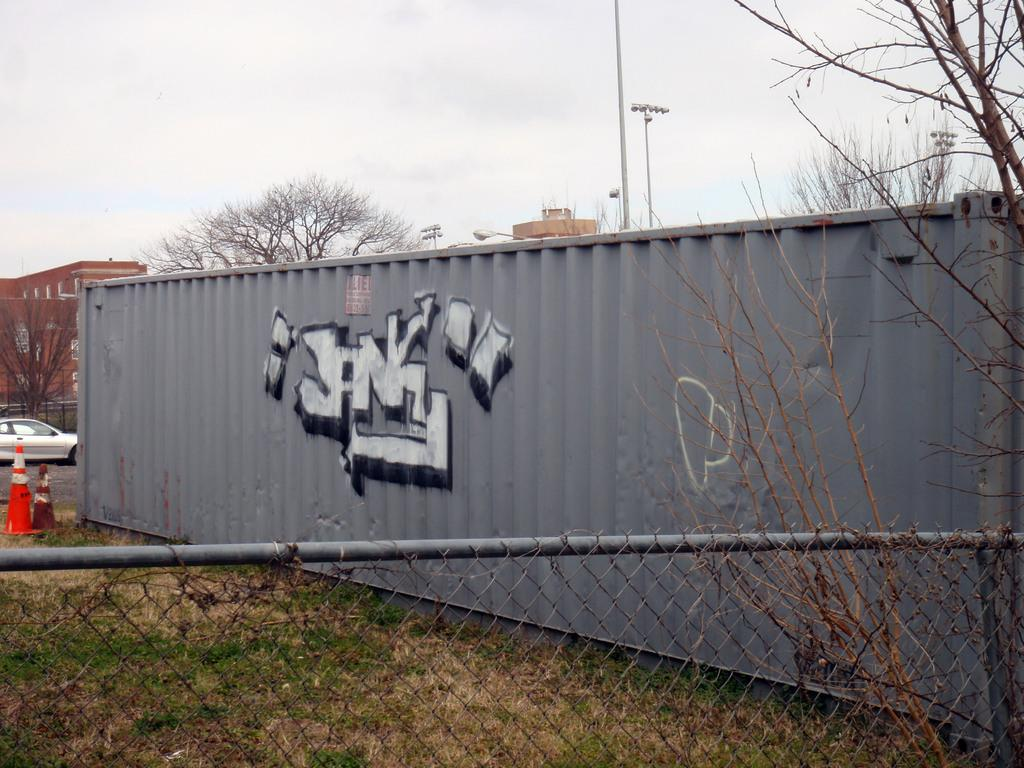Provide a one-sentence caption for the provided image. A large grey shipping container has graffiti on it that says Jank. 